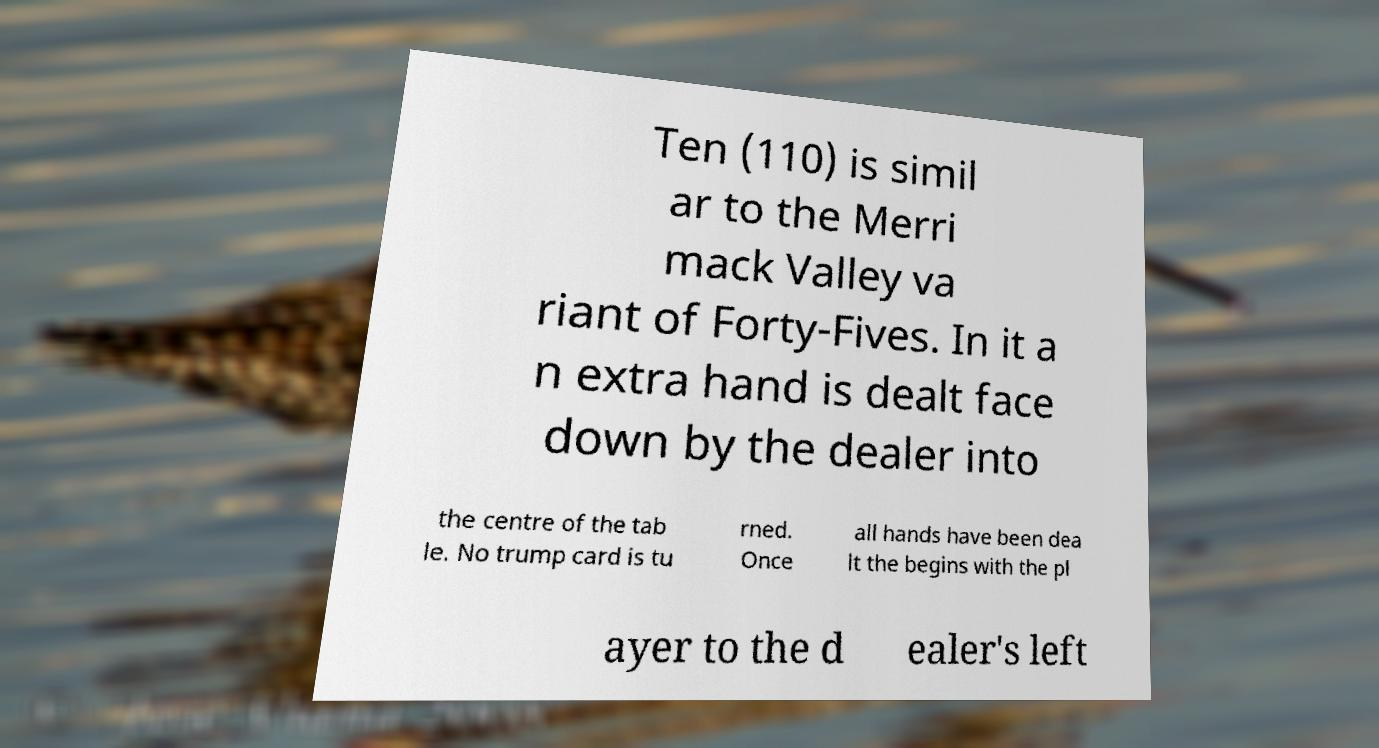Could you extract and type out the text from this image? Ten (110) is simil ar to the Merri mack Valley va riant of Forty-Fives. In it a n extra hand is dealt face down by the dealer into the centre of the tab le. No trump card is tu rned. Once all hands have been dea lt the begins with the pl ayer to the d ealer's left 